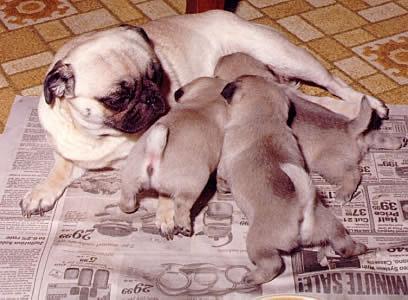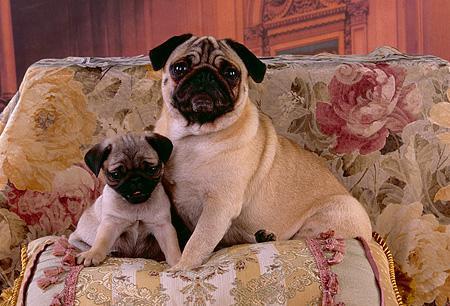The first image is the image on the left, the second image is the image on the right. Considering the images on both sides, is "There are exactly two dogs in one of the images." valid? Answer yes or no. Yes. The first image is the image on the left, the second image is the image on the right. Evaluate the accuracy of this statement regarding the images: "There is an adult pug in each image.". Is it true? Answer yes or no. Yes. 